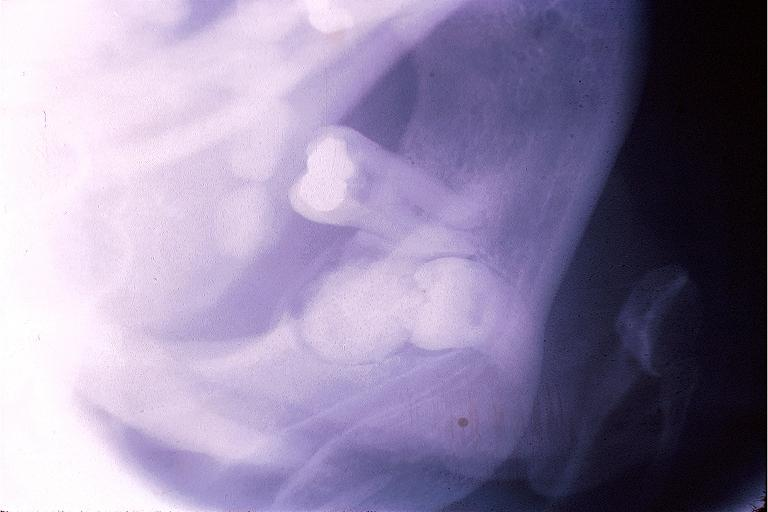where is this?
Answer the question using a single word or phrase. Oral 